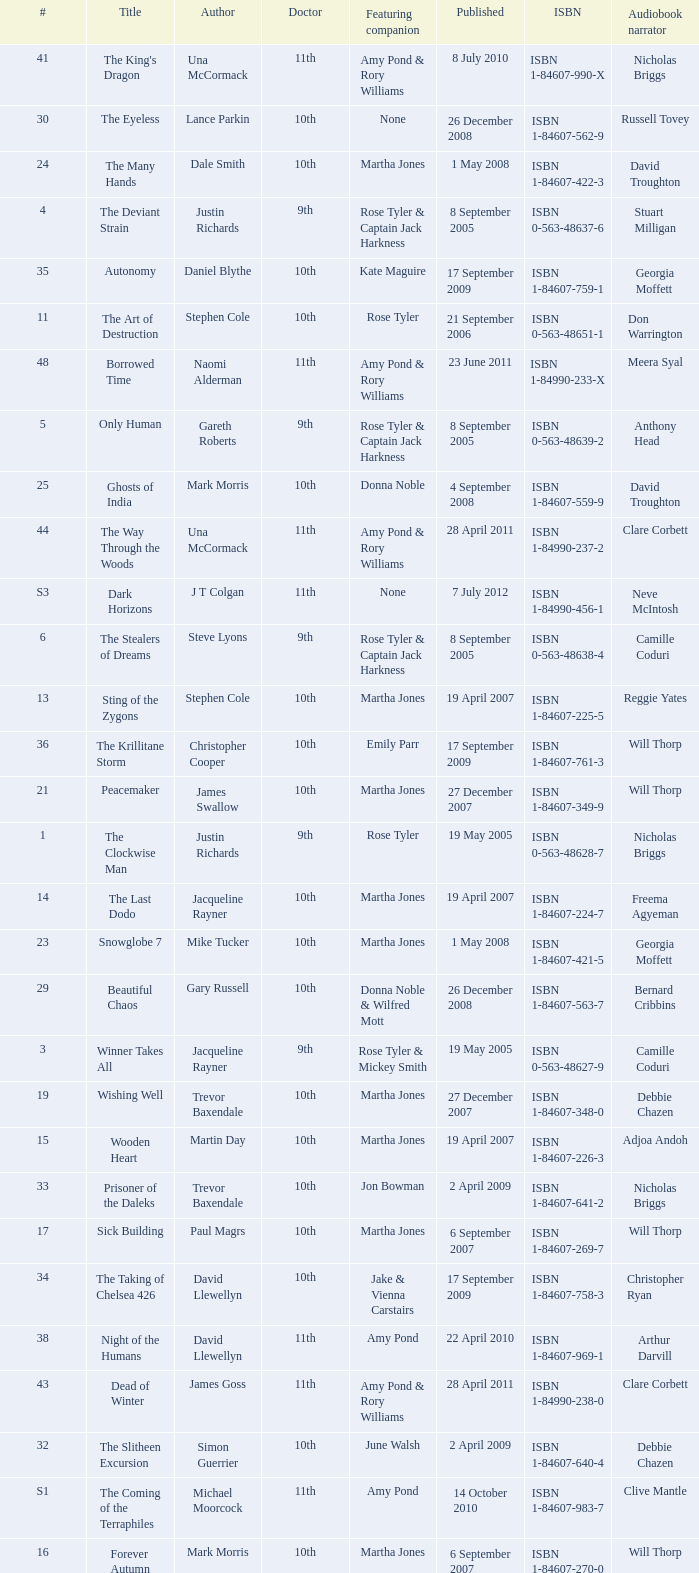What is the publication date of the book that is narrated by Michael Maloney? 29 September 2011. 